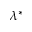Convert formula to latex. <formula><loc_0><loc_0><loc_500><loc_500>\lambda ^ { * }</formula> 